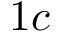<formula> <loc_0><loc_0><loc_500><loc_500>1 c</formula> 